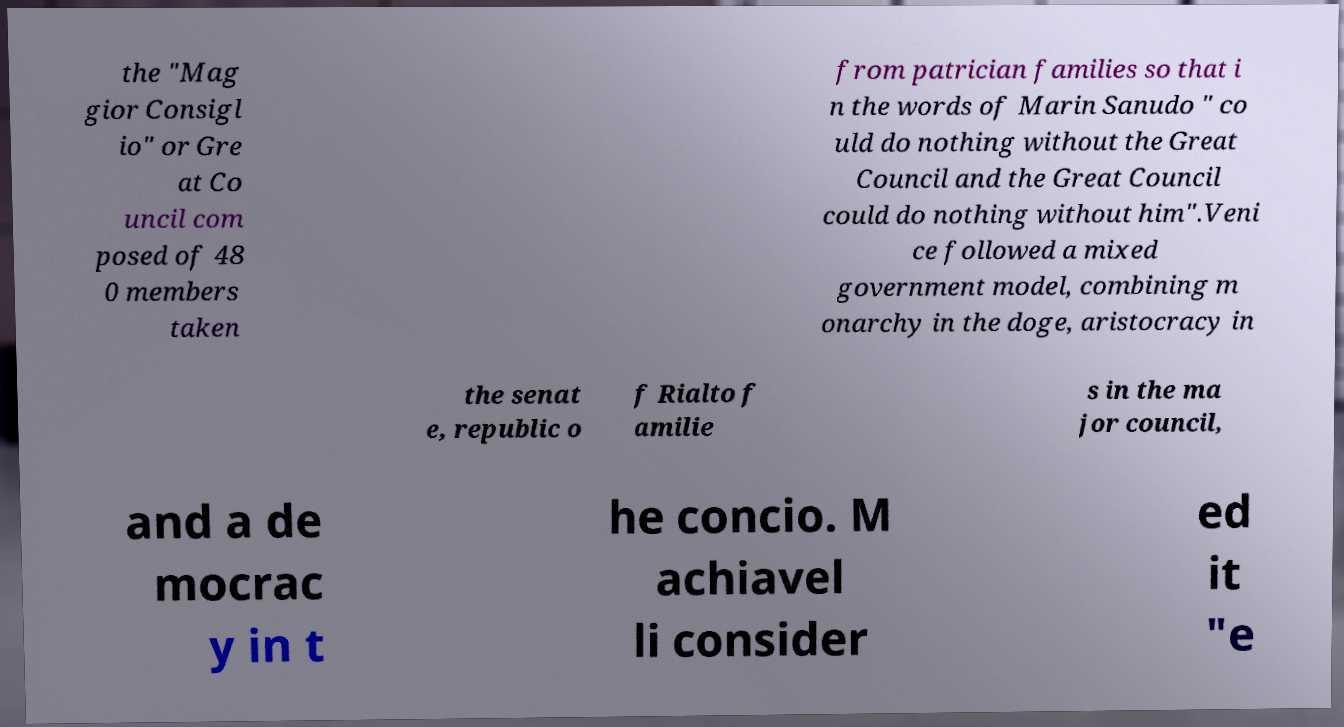Can you accurately transcribe the text from the provided image for me? the "Mag gior Consigl io" or Gre at Co uncil com posed of 48 0 members taken from patrician families so that i n the words of Marin Sanudo " co uld do nothing without the Great Council and the Great Council could do nothing without him".Veni ce followed a mixed government model, combining m onarchy in the doge, aristocracy in the senat e, republic o f Rialto f amilie s in the ma jor council, and a de mocrac y in t he concio. M achiavel li consider ed it "e 